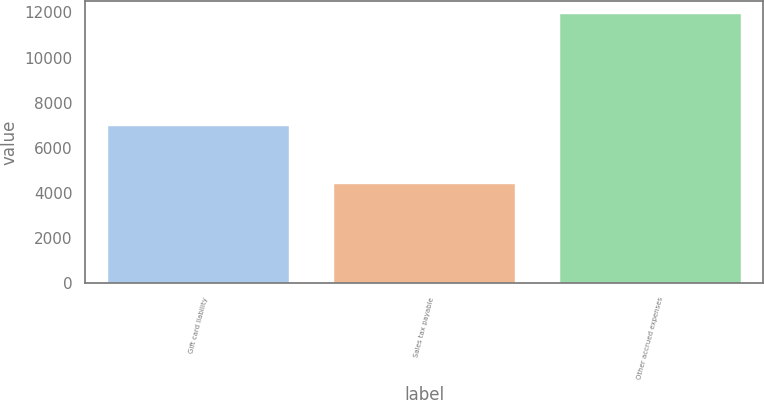Convert chart. <chart><loc_0><loc_0><loc_500><loc_500><bar_chart><fcel>Gift card liability<fcel>Sales tax payable<fcel>Other accrued expenses<nl><fcel>6984<fcel>4381<fcel>11912<nl></chart> 